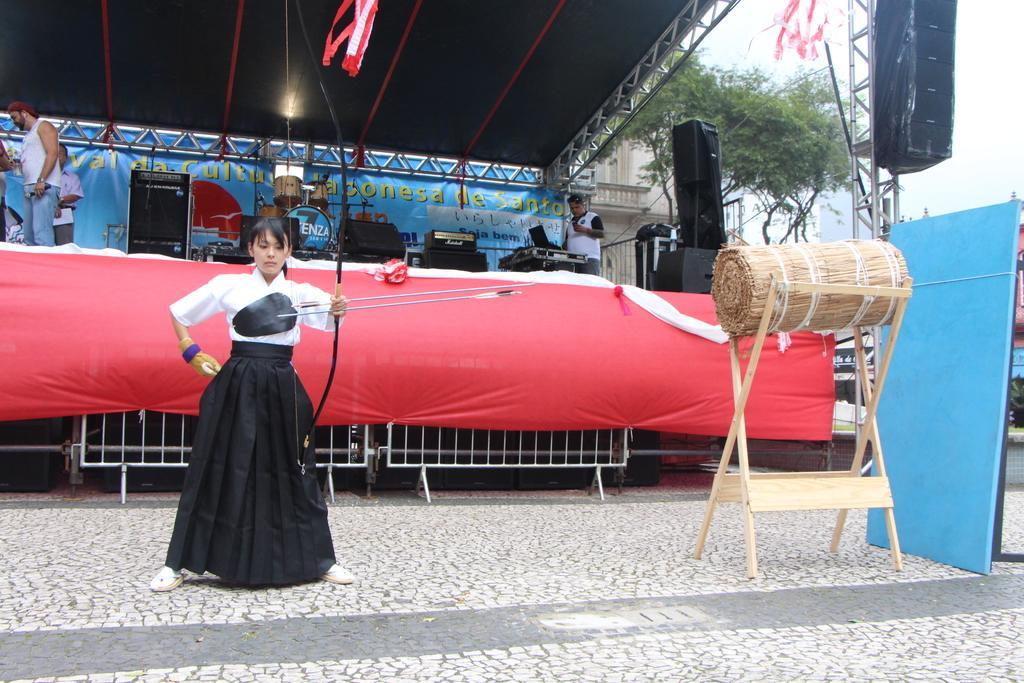Can you describe this image briefly? In this picture there is a woman who is holding arrow. She is standing on the floor. On the right we can see the banners near to the wooden stand. On the stage we can see two persons standing near the speakers. On the right background we can see the buildings and tree. In the top right corner there is a sky. 